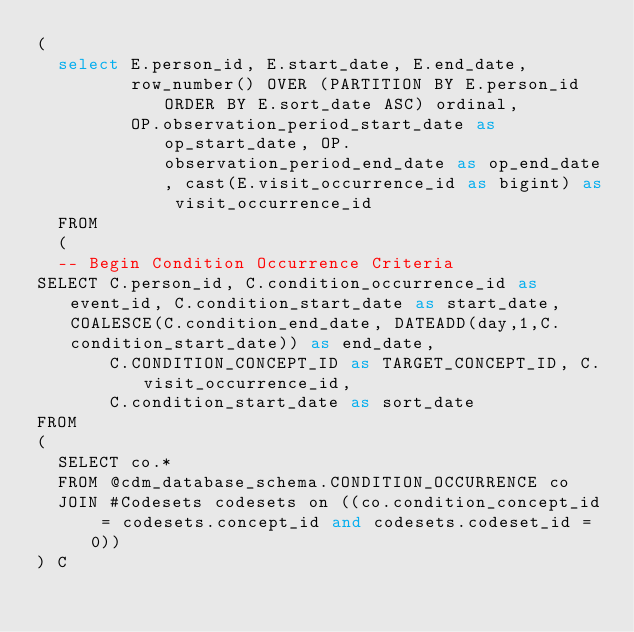Convert code to text. <code><loc_0><loc_0><loc_500><loc_500><_SQL_>(
  select E.person_id, E.start_date, E.end_date,
         row_number() OVER (PARTITION BY E.person_id ORDER BY E.sort_date ASC) ordinal,
         OP.observation_period_start_date as op_start_date, OP.observation_period_end_date as op_end_date, cast(E.visit_occurrence_id as bigint) as visit_occurrence_id
  FROM 
  (
  -- Begin Condition Occurrence Criteria
SELECT C.person_id, C.condition_occurrence_id as event_id, C.condition_start_date as start_date, COALESCE(C.condition_end_date, DATEADD(day,1,C.condition_start_date)) as end_date,
       C.CONDITION_CONCEPT_ID as TARGET_CONCEPT_ID, C.visit_occurrence_id,
       C.condition_start_date as sort_date
FROM 
(
  SELECT co.* 
  FROM @cdm_database_schema.CONDITION_OCCURRENCE co
  JOIN #Codesets codesets on ((co.condition_concept_id = codesets.concept_id and codesets.codeset_id = 0))
) C</code> 